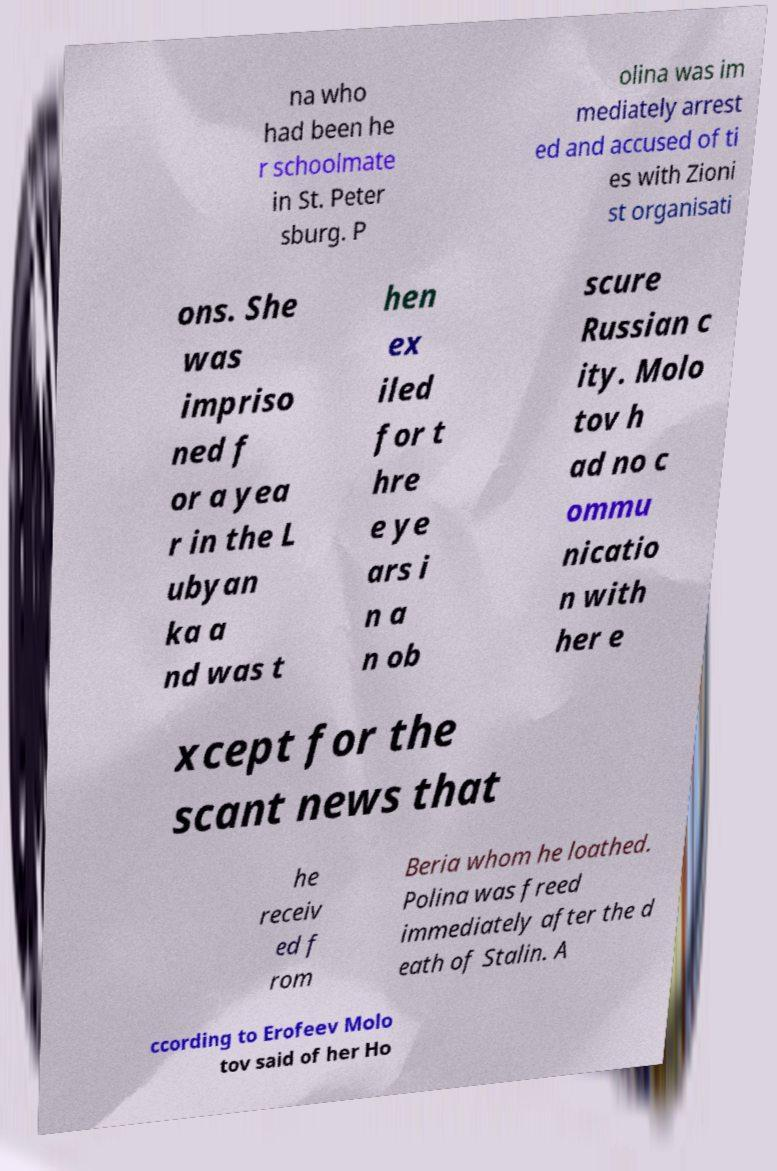There's text embedded in this image that I need extracted. Can you transcribe it verbatim? na who had been he r schoolmate in St. Peter sburg. P olina was im mediately arrest ed and accused of ti es with Zioni st organisati ons. She was impriso ned f or a yea r in the L ubyan ka a nd was t hen ex iled for t hre e ye ars i n a n ob scure Russian c ity. Molo tov h ad no c ommu nicatio n with her e xcept for the scant news that he receiv ed f rom Beria whom he loathed. Polina was freed immediately after the d eath of Stalin. A ccording to Erofeev Molo tov said of her Ho 